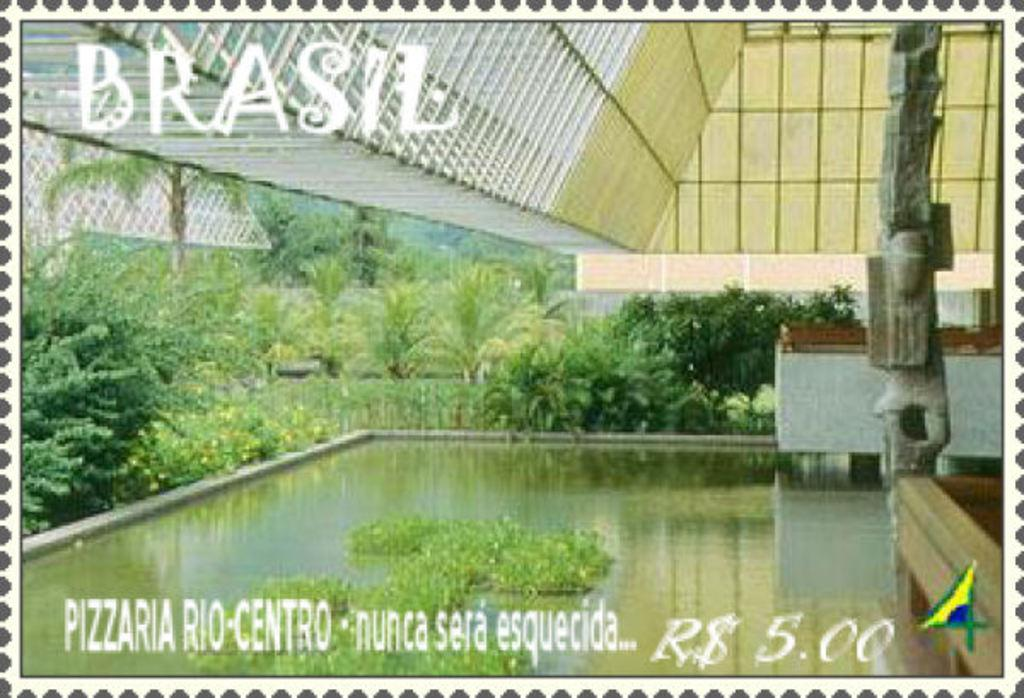What is the main subject of the poster in the image? The poster depicts a water surface. What other elements are included in the poster? The poster includes plants, trees, and a part of a house. What health advice is given on the poster? There is no health advice present on the poster; it depicts a water surface with plants, trees, and a part of a house. 